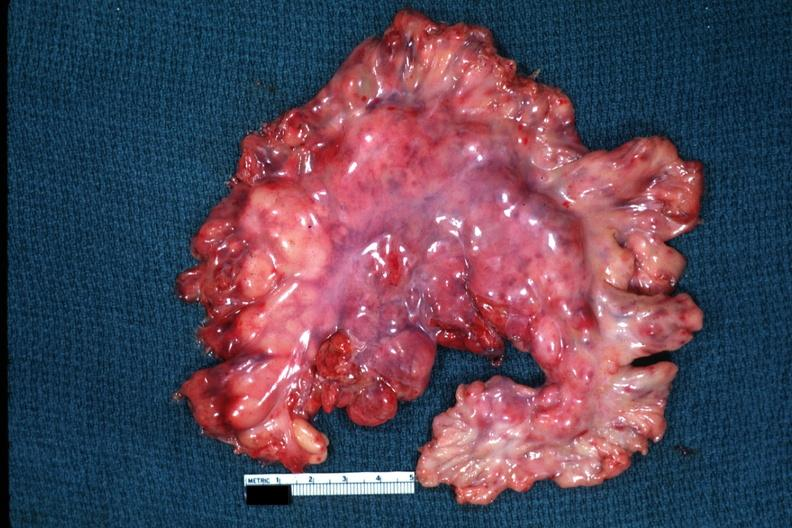s tuberculous peritonitis present?
Answer the question using a single word or phrase. No 